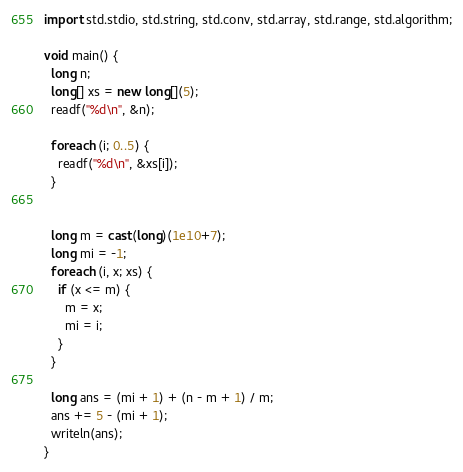<code> <loc_0><loc_0><loc_500><loc_500><_D_>import std.stdio, std.string, std.conv, std.array, std.range, std.algorithm;

void main() {
  long n;
  long[] xs = new long[](5);
  readf("%d\n", &n);

  foreach (i; 0..5) {
    readf("%d\n", &xs[i]);
  }


  long m = cast(long)(1e10+7);
  long mi = -1;
  foreach (i, x; xs) {
    if (x <= m) {
      m = x;
      mi = i;
    }
  }

  long ans = (mi + 1) + (n - m + 1) / m;
  ans += 5 - (mi + 1);
  writeln(ans);
}
</code> 